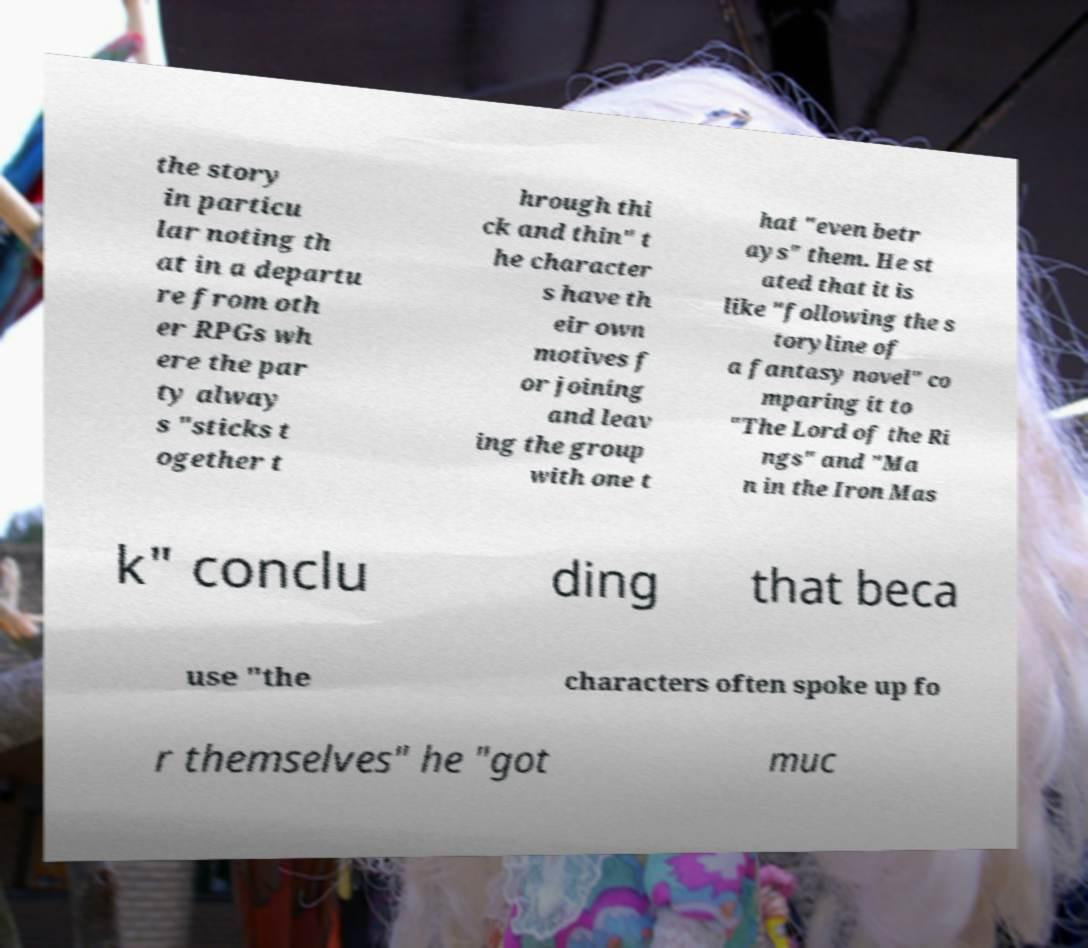For documentation purposes, I need the text within this image transcribed. Could you provide that? the story in particu lar noting th at in a departu re from oth er RPGs wh ere the par ty alway s "sticks t ogether t hrough thi ck and thin" t he character s have th eir own motives f or joining and leav ing the group with one t hat "even betr ays" them. He st ated that it is like "following the s toryline of a fantasy novel" co mparing it to "The Lord of the Ri ngs" and "Ma n in the Iron Mas k" conclu ding that beca use "the characters often spoke up fo r themselves" he "got muc 